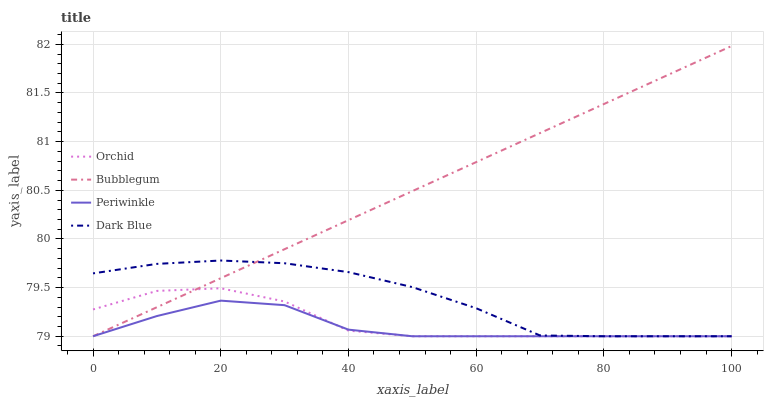Does Periwinkle have the minimum area under the curve?
Answer yes or no. Yes. Does Bubblegum have the maximum area under the curve?
Answer yes or no. Yes. Does Bubblegum have the minimum area under the curve?
Answer yes or no. No. Does Periwinkle have the maximum area under the curve?
Answer yes or no. No. Is Bubblegum the smoothest?
Answer yes or no. Yes. Is Orchid the roughest?
Answer yes or no. Yes. Is Periwinkle the smoothest?
Answer yes or no. No. Is Periwinkle the roughest?
Answer yes or no. No. Does Dark Blue have the lowest value?
Answer yes or no. Yes. Does Bubblegum have the highest value?
Answer yes or no. Yes. Does Periwinkle have the highest value?
Answer yes or no. No. Does Periwinkle intersect Orchid?
Answer yes or no. Yes. Is Periwinkle less than Orchid?
Answer yes or no. No. Is Periwinkle greater than Orchid?
Answer yes or no. No. 